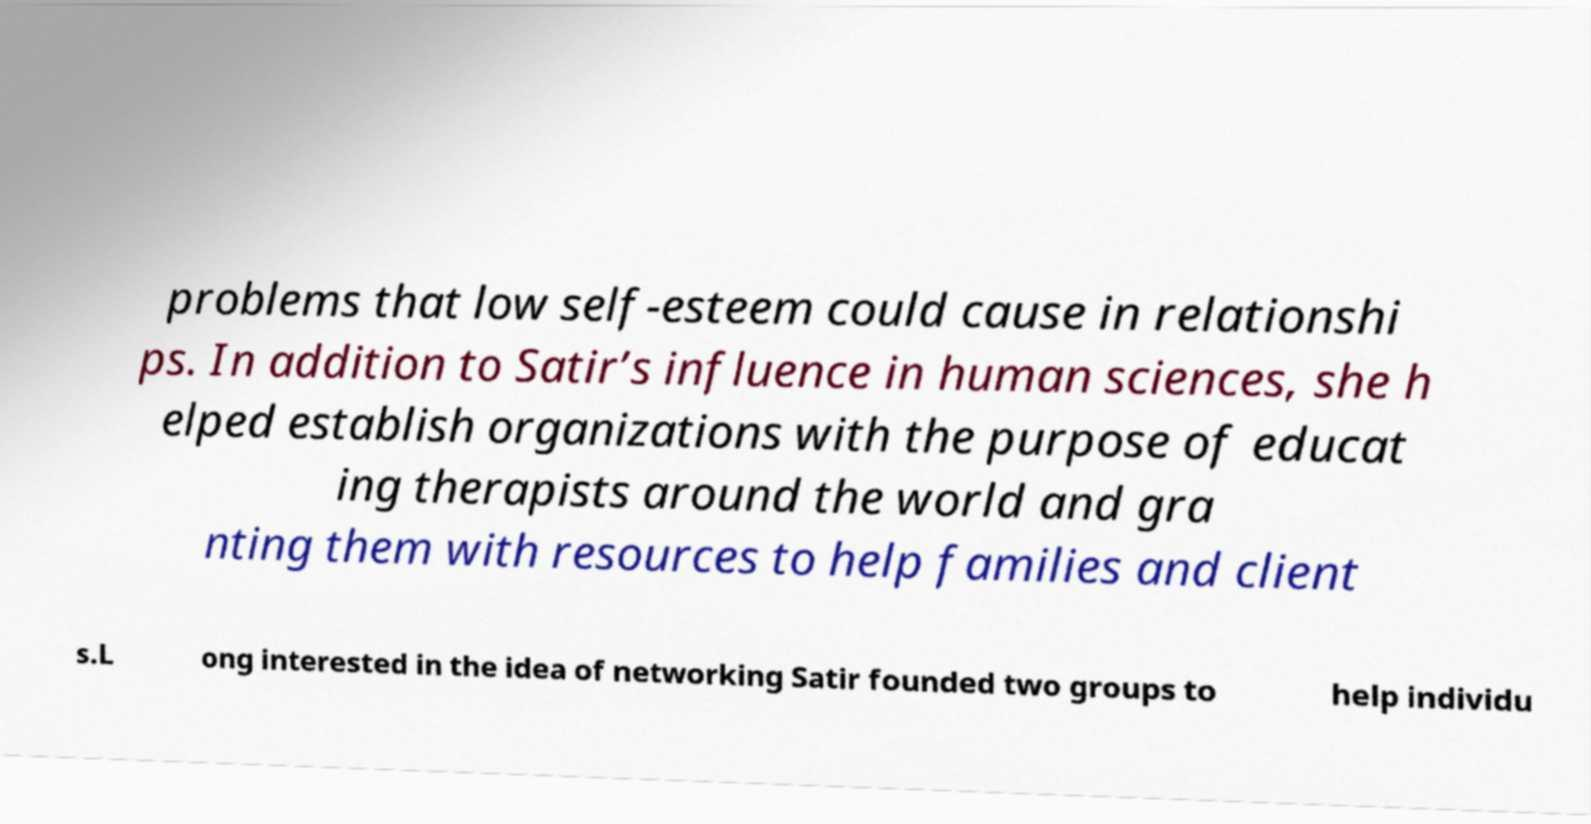Please identify and transcribe the text found in this image. problems that low self-esteem could cause in relationshi ps. In addition to Satir’s influence in human sciences, she h elped establish organizations with the purpose of educat ing therapists around the world and gra nting them with resources to help families and client s.L ong interested in the idea of networking Satir founded two groups to help individu 